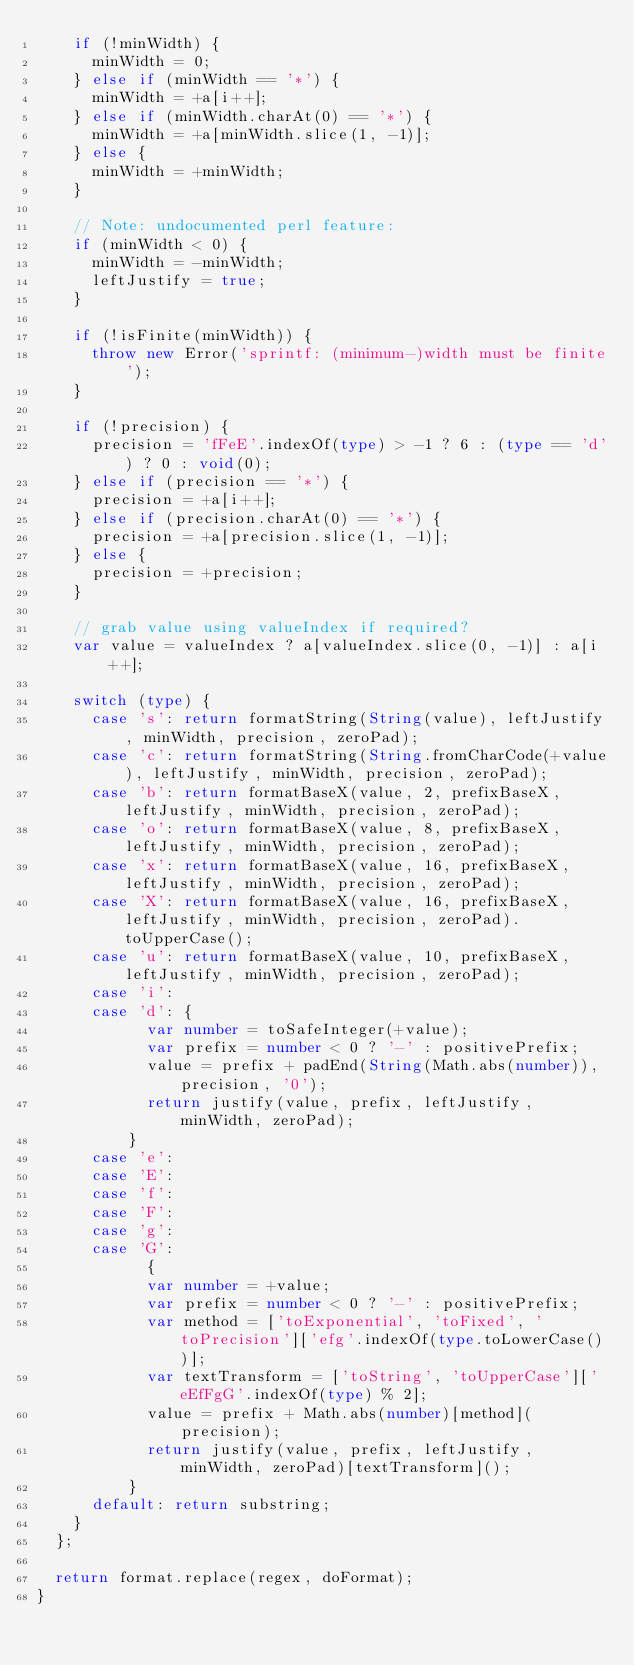<code> <loc_0><loc_0><loc_500><loc_500><_TypeScript_>		if (!minWidth) {
			minWidth = 0;
		} else if (minWidth == '*') {
			minWidth = +a[i++];
		} else if (minWidth.charAt(0) == '*') {
			minWidth = +a[minWidth.slice(1, -1)];
		} else {
			minWidth = +minWidth;
		}

		// Note: undocumented perl feature:
		if (minWidth < 0) {
			minWidth = -minWidth;
			leftJustify = true;
		}

		if (!isFinite(minWidth)) {
			throw new Error('sprintf: (minimum-)width must be finite');
		}

		if (!precision) {
			precision = 'fFeE'.indexOf(type) > -1 ? 6 : (type == 'd') ? 0 : void(0);
		} else if (precision == '*') {
			precision = +a[i++];
		} else if (precision.charAt(0) == '*') {
			precision = +a[precision.slice(1, -1)];
		} else {
			precision = +precision;
		}

		// grab value using valueIndex if required?
		var value = valueIndex ? a[valueIndex.slice(0, -1)] : a[i++];

		switch (type) {
			case 's': return formatString(String(value), leftJustify, minWidth, precision, zeroPad);
			case 'c': return formatString(String.fromCharCode(+value), leftJustify, minWidth, precision, zeroPad);
			case 'b': return formatBaseX(value, 2, prefixBaseX, leftJustify, minWidth, precision, zeroPad);
			case 'o': return formatBaseX(value, 8, prefixBaseX, leftJustify, minWidth, precision, zeroPad);
			case 'x': return formatBaseX(value, 16, prefixBaseX, leftJustify, minWidth, precision, zeroPad);
			case 'X': return formatBaseX(value, 16, prefixBaseX, leftJustify, minWidth, precision, zeroPad).toUpperCase();
			case 'u': return formatBaseX(value, 10, prefixBaseX, leftJustify, minWidth, precision, zeroPad);
			case 'i':
			case 'd': {
						var number = toSafeInteger(+value);
						var prefix = number < 0 ? '-' : positivePrefix;
						value = prefix + padEnd(String(Math.abs(number)), precision, '0');
						return justify(value, prefix, leftJustify, minWidth, zeroPad);
					}
			case 'e':
			case 'E':
			case 'f':
			case 'F':
			case 'g':
			case 'G':
						{
						var number = +value;
						var prefix = number < 0 ? '-' : positivePrefix;
						var method = ['toExponential', 'toFixed', 'toPrecision']['efg'.indexOf(type.toLowerCase())];
						var textTransform = ['toString', 'toUpperCase']['eEfFgG'.indexOf(type) % 2];
						value = prefix + Math.abs(number)[method](precision);
						return justify(value, prefix, leftJustify, minWidth, zeroPad)[textTransform]();
					}
			default: return substring;
		}
	};

	return format.replace(regex, doFormat);
}</code> 